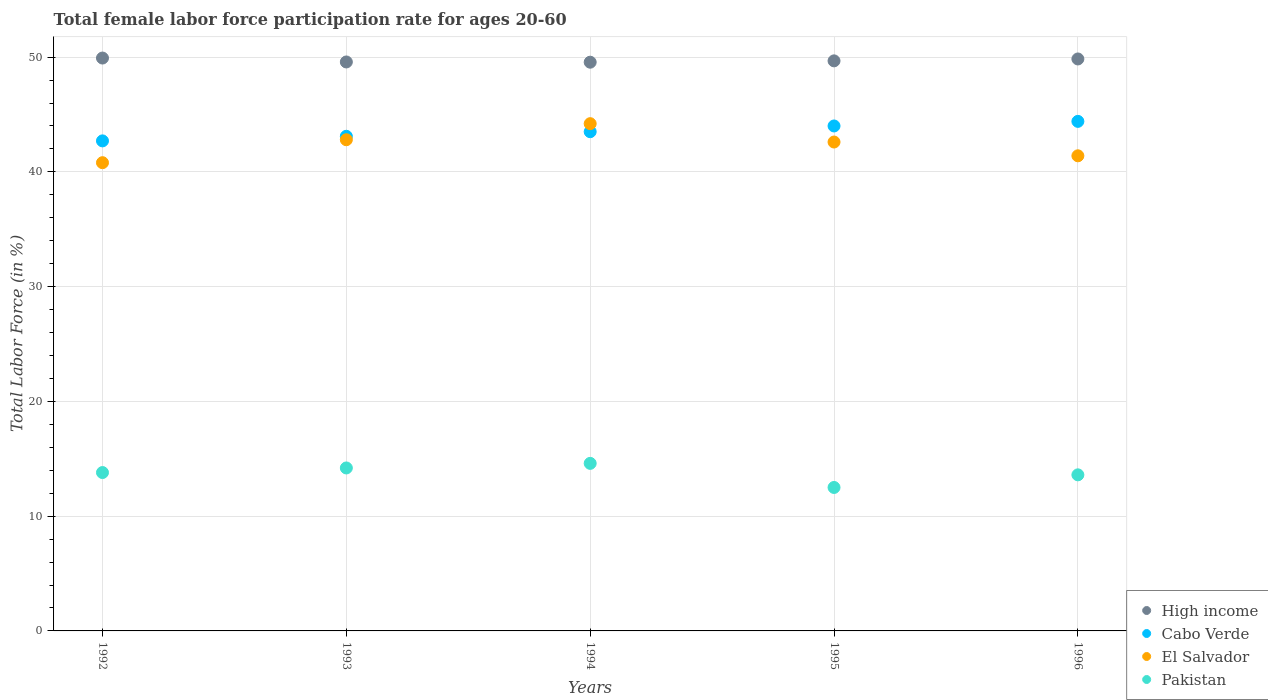What is the female labor force participation rate in Pakistan in 1996?
Offer a very short reply. 13.6. Across all years, what is the maximum female labor force participation rate in High income?
Give a very brief answer. 49.92. Across all years, what is the minimum female labor force participation rate in Cabo Verde?
Provide a short and direct response. 42.7. In which year was the female labor force participation rate in High income maximum?
Your response must be concise. 1992. In which year was the female labor force participation rate in Cabo Verde minimum?
Your response must be concise. 1992. What is the total female labor force participation rate in High income in the graph?
Ensure brevity in your answer.  248.56. What is the difference between the female labor force participation rate in El Salvador in 1992 and that in 1996?
Ensure brevity in your answer.  -0.6. What is the difference between the female labor force participation rate in El Salvador in 1993 and the female labor force participation rate in Cabo Verde in 1995?
Ensure brevity in your answer.  -1.2. What is the average female labor force participation rate in High income per year?
Provide a succinct answer. 49.71. In the year 1995, what is the difference between the female labor force participation rate in Pakistan and female labor force participation rate in High income?
Provide a succinct answer. -37.17. What is the ratio of the female labor force participation rate in Pakistan in 1993 to that in 1996?
Ensure brevity in your answer.  1.04. Is the female labor force participation rate in El Salvador in 1992 less than that in 1996?
Give a very brief answer. Yes. Is the difference between the female labor force participation rate in Pakistan in 1992 and 1995 greater than the difference between the female labor force participation rate in High income in 1992 and 1995?
Give a very brief answer. Yes. What is the difference between the highest and the second highest female labor force participation rate in Pakistan?
Your answer should be compact. 0.4. What is the difference between the highest and the lowest female labor force participation rate in High income?
Give a very brief answer. 0.36. In how many years, is the female labor force participation rate in El Salvador greater than the average female labor force participation rate in El Salvador taken over all years?
Give a very brief answer. 3. Is the sum of the female labor force participation rate in El Salvador in 1993 and 1994 greater than the maximum female labor force participation rate in Pakistan across all years?
Ensure brevity in your answer.  Yes. Does the female labor force participation rate in Cabo Verde monotonically increase over the years?
Provide a short and direct response. Yes. Is the female labor force participation rate in Pakistan strictly less than the female labor force participation rate in Cabo Verde over the years?
Ensure brevity in your answer.  Yes. Are the values on the major ticks of Y-axis written in scientific E-notation?
Offer a terse response. No. Where does the legend appear in the graph?
Provide a succinct answer. Bottom right. What is the title of the graph?
Your response must be concise. Total female labor force participation rate for ages 20-60. What is the Total Labor Force (in %) in High income in 1992?
Provide a short and direct response. 49.92. What is the Total Labor Force (in %) in Cabo Verde in 1992?
Provide a short and direct response. 42.7. What is the Total Labor Force (in %) in El Salvador in 1992?
Provide a short and direct response. 40.8. What is the Total Labor Force (in %) in Pakistan in 1992?
Keep it short and to the point. 13.8. What is the Total Labor Force (in %) of High income in 1993?
Offer a very short reply. 49.58. What is the Total Labor Force (in %) of Cabo Verde in 1993?
Ensure brevity in your answer.  43.1. What is the Total Labor Force (in %) of El Salvador in 1993?
Your answer should be compact. 42.8. What is the Total Labor Force (in %) in Pakistan in 1993?
Provide a succinct answer. 14.2. What is the Total Labor Force (in %) in High income in 1994?
Provide a short and direct response. 49.56. What is the Total Labor Force (in %) of Cabo Verde in 1994?
Offer a very short reply. 43.5. What is the Total Labor Force (in %) of El Salvador in 1994?
Ensure brevity in your answer.  44.2. What is the Total Labor Force (in %) of Pakistan in 1994?
Your answer should be very brief. 14.6. What is the Total Labor Force (in %) in High income in 1995?
Make the answer very short. 49.67. What is the Total Labor Force (in %) in Cabo Verde in 1995?
Your answer should be compact. 44. What is the Total Labor Force (in %) in El Salvador in 1995?
Keep it short and to the point. 42.6. What is the Total Labor Force (in %) in High income in 1996?
Make the answer very short. 49.84. What is the Total Labor Force (in %) in Cabo Verde in 1996?
Your answer should be compact. 44.4. What is the Total Labor Force (in %) in El Salvador in 1996?
Offer a terse response. 41.4. What is the Total Labor Force (in %) of Pakistan in 1996?
Your answer should be compact. 13.6. Across all years, what is the maximum Total Labor Force (in %) in High income?
Provide a succinct answer. 49.92. Across all years, what is the maximum Total Labor Force (in %) in Cabo Verde?
Your answer should be compact. 44.4. Across all years, what is the maximum Total Labor Force (in %) in El Salvador?
Your answer should be compact. 44.2. Across all years, what is the maximum Total Labor Force (in %) in Pakistan?
Keep it short and to the point. 14.6. Across all years, what is the minimum Total Labor Force (in %) of High income?
Provide a succinct answer. 49.56. Across all years, what is the minimum Total Labor Force (in %) in Cabo Verde?
Ensure brevity in your answer.  42.7. Across all years, what is the minimum Total Labor Force (in %) in El Salvador?
Offer a terse response. 40.8. What is the total Total Labor Force (in %) in High income in the graph?
Your answer should be compact. 248.56. What is the total Total Labor Force (in %) in Cabo Verde in the graph?
Make the answer very short. 217.7. What is the total Total Labor Force (in %) in El Salvador in the graph?
Make the answer very short. 211.8. What is the total Total Labor Force (in %) in Pakistan in the graph?
Your answer should be compact. 68.7. What is the difference between the Total Labor Force (in %) of High income in 1992 and that in 1993?
Your answer should be compact. 0.34. What is the difference between the Total Labor Force (in %) of Cabo Verde in 1992 and that in 1993?
Your answer should be very brief. -0.4. What is the difference between the Total Labor Force (in %) in High income in 1992 and that in 1994?
Your answer should be very brief. 0.36. What is the difference between the Total Labor Force (in %) of Cabo Verde in 1992 and that in 1994?
Offer a very short reply. -0.8. What is the difference between the Total Labor Force (in %) in El Salvador in 1992 and that in 1994?
Keep it short and to the point. -3.4. What is the difference between the Total Labor Force (in %) of High income in 1992 and that in 1995?
Ensure brevity in your answer.  0.25. What is the difference between the Total Labor Force (in %) in El Salvador in 1992 and that in 1995?
Your answer should be very brief. -1.8. What is the difference between the Total Labor Force (in %) in High income in 1992 and that in 1996?
Provide a succinct answer. 0.08. What is the difference between the Total Labor Force (in %) in El Salvador in 1992 and that in 1996?
Provide a short and direct response. -0.6. What is the difference between the Total Labor Force (in %) of Pakistan in 1992 and that in 1996?
Your answer should be compact. 0.2. What is the difference between the Total Labor Force (in %) of High income in 1993 and that in 1994?
Provide a short and direct response. 0.02. What is the difference between the Total Labor Force (in %) of Cabo Verde in 1993 and that in 1994?
Your response must be concise. -0.4. What is the difference between the Total Labor Force (in %) of High income in 1993 and that in 1995?
Ensure brevity in your answer.  -0.1. What is the difference between the Total Labor Force (in %) of Cabo Verde in 1993 and that in 1995?
Your response must be concise. -0.9. What is the difference between the Total Labor Force (in %) of Pakistan in 1993 and that in 1995?
Provide a succinct answer. 1.7. What is the difference between the Total Labor Force (in %) of High income in 1993 and that in 1996?
Give a very brief answer. -0.26. What is the difference between the Total Labor Force (in %) of Pakistan in 1993 and that in 1996?
Ensure brevity in your answer.  0.6. What is the difference between the Total Labor Force (in %) of High income in 1994 and that in 1995?
Offer a terse response. -0.12. What is the difference between the Total Labor Force (in %) in Cabo Verde in 1994 and that in 1995?
Ensure brevity in your answer.  -0.5. What is the difference between the Total Labor Force (in %) in El Salvador in 1994 and that in 1995?
Offer a very short reply. 1.6. What is the difference between the Total Labor Force (in %) in Pakistan in 1994 and that in 1995?
Make the answer very short. 2.1. What is the difference between the Total Labor Force (in %) in High income in 1994 and that in 1996?
Offer a very short reply. -0.28. What is the difference between the Total Labor Force (in %) in El Salvador in 1994 and that in 1996?
Give a very brief answer. 2.8. What is the difference between the Total Labor Force (in %) of High income in 1995 and that in 1996?
Give a very brief answer. -0.17. What is the difference between the Total Labor Force (in %) in High income in 1992 and the Total Labor Force (in %) in Cabo Verde in 1993?
Provide a short and direct response. 6.82. What is the difference between the Total Labor Force (in %) in High income in 1992 and the Total Labor Force (in %) in El Salvador in 1993?
Your answer should be compact. 7.12. What is the difference between the Total Labor Force (in %) of High income in 1992 and the Total Labor Force (in %) of Pakistan in 1993?
Your answer should be compact. 35.72. What is the difference between the Total Labor Force (in %) in El Salvador in 1992 and the Total Labor Force (in %) in Pakistan in 1993?
Ensure brevity in your answer.  26.6. What is the difference between the Total Labor Force (in %) of High income in 1992 and the Total Labor Force (in %) of Cabo Verde in 1994?
Give a very brief answer. 6.42. What is the difference between the Total Labor Force (in %) of High income in 1992 and the Total Labor Force (in %) of El Salvador in 1994?
Offer a terse response. 5.72. What is the difference between the Total Labor Force (in %) of High income in 1992 and the Total Labor Force (in %) of Pakistan in 1994?
Your answer should be very brief. 35.32. What is the difference between the Total Labor Force (in %) in Cabo Verde in 1992 and the Total Labor Force (in %) in El Salvador in 1994?
Your answer should be compact. -1.5. What is the difference between the Total Labor Force (in %) of Cabo Verde in 1992 and the Total Labor Force (in %) of Pakistan in 1994?
Give a very brief answer. 28.1. What is the difference between the Total Labor Force (in %) in El Salvador in 1992 and the Total Labor Force (in %) in Pakistan in 1994?
Your answer should be compact. 26.2. What is the difference between the Total Labor Force (in %) of High income in 1992 and the Total Labor Force (in %) of Cabo Verde in 1995?
Offer a very short reply. 5.92. What is the difference between the Total Labor Force (in %) of High income in 1992 and the Total Labor Force (in %) of El Salvador in 1995?
Ensure brevity in your answer.  7.32. What is the difference between the Total Labor Force (in %) in High income in 1992 and the Total Labor Force (in %) in Pakistan in 1995?
Your answer should be compact. 37.42. What is the difference between the Total Labor Force (in %) in Cabo Verde in 1992 and the Total Labor Force (in %) in Pakistan in 1995?
Provide a short and direct response. 30.2. What is the difference between the Total Labor Force (in %) in El Salvador in 1992 and the Total Labor Force (in %) in Pakistan in 1995?
Make the answer very short. 28.3. What is the difference between the Total Labor Force (in %) of High income in 1992 and the Total Labor Force (in %) of Cabo Verde in 1996?
Provide a short and direct response. 5.52. What is the difference between the Total Labor Force (in %) of High income in 1992 and the Total Labor Force (in %) of El Salvador in 1996?
Ensure brevity in your answer.  8.52. What is the difference between the Total Labor Force (in %) in High income in 1992 and the Total Labor Force (in %) in Pakistan in 1996?
Offer a very short reply. 36.32. What is the difference between the Total Labor Force (in %) in Cabo Verde in 1992 and the Total Labor Force (in %) in Pakistan in 1996?
Offer a very short reply. 29.1. What is the difference between the Total Labor Force (in %) in El Salvador in 1992 and the Total Labor Force (in %) in Pakistan in 1996?
Your answer should be very brief. 27.2. What is the difference between the Total Labor Force (in %) in High income in 1993 and the Total Labor Force (in %) in Cabo Verde in 1994?
Give a very brief answer. 6.08. What is the difference between the Total Labor Force (in %) of High income in 1993 and the Total Labor Force (in %) of El Salvador in 1994?
Keep it short and to the point. 5.38. What is the difference between the Total Labor Force (in %) in High income in 1993 and the Total Labor Force (in %) in Pakistan in 1994?
Keep it short and to the point. 34.98. What is the difference between the Total Labor Force (in %) in Cabo Verde in 1993 and the Total Labor Force (in %) in El Salvador in 1994?
Keep it short and to the point. -1.1. What is the difference between the Total Labor Force (in %) of Cabo Verde in 1993 and the Total Labor Force (in %) of Pakistan in 1994?
Offer a terse response. 28.5. What is the difference between the Total Labor Force (in %) of El Salvador in 1993 and the Total Labor Force (in %) of Pakistan in 1994?
Make the answer very short. 28.2. What is the difference between the Total Labor Force (in %) of High income in 1993 and the Total Labor Force (in %) of Cabo Verde in 1995?
Your answer should be compact. 5.58. What is the difference between the Total Labor Force (in %) of High income in 1993 and the Total Labor Force (in %) of El Salvador in 1995?
Your response must be concise. 6.98. What is the difference between the Total Labor Force (in %) in High income in 1993 and the Total Labor Force (in %) in Pakistan in 1995?
Provide a succinct answer. 37.08. What is the difference between the Total Labor Force (in %) in Cabo Verde in 1993 and the Total Labor Force (in %) in El Salvador in 1995?
Keep it short and to the point. 0.5. What is the difference between the Total Labor Force (in %) in Cabo Verde in 1993 and the Total Labor Force (in %) in Pakistan in 1995?
Your answer should be compact. 30.6. What is the difference between the Total Labor Force (in %) of El Salvador in 1993 and the Total Labor Force (in %) of Pakistan in 1995?
Offer a very short reply. 30.3. What is the difference between the Total Labor Force (in %) in High income in 1993 and the Total Labor Force (in %) in Cabo Verde in 1996?
Provide a short and direct response. 5.18. What is the difference between the Total Labor Force (in %) of High income in 1993 and the Total Labor Force (in %) of El Salvador in 1996?
Make the answer very short. 8.18. What is the difference between the Total Labor Force (in %) in High income in 1993 and the Total Labor Force (in %) in Pakistan in 1996?
Your answer should be compact. 35.98. What is the difference between the Total Labor Force (in %) of Cabo Verde in 1993 and the Total Labor Force (in %) of Pakistan in 1996?
Offer a very short reply. 29.5. What is the difference between the Total Labor Force (in %) of El Salvador in 1993 and the Total Labor Force (in %) of Pakistan in 1996?
Provide a short and direct response. 29.2. What is the difference between the Total Labor Force (in %) in High income in 1994 and the Total Labor Force (in %) in Cabo Verde in 1995?
Offer a very short reply. 5.56. What is the difference between the Total Labor Force (in %) in High income in 1994 and the Total Labor Force (in %) in El Salvador in 1995?
Give a very brief answer. 6.96. What is the difference between the Total Labor Force (in %) of High income in 1994 and the Total Labor Force (in %) of Pakistan in 1995?
Your answer should be compact. 37.06. What is the difference between the Total Labor Force (in %) in El Salvador in 1994 and the Total Labor Force (in %) in Pakistan in 1995?
Provide a short and direct response. 31.7. What is the difference between the Total Labor Force (in %) in High income in 1994 and the Total Labor Force (in %) in Cabo Verde in 1996?
Provide a short and direct response. 5.16. What is the difference between the Total Labor Force (in %) in High income in 1994 and the Total Labor Force (in %) in El Salvador in 1996?
Keep it short and to the point. 8.16. What is the difference between the Total Labor Force (in %) in High income in 1994 and the Total Labor Force (in %) in Pakistan in 1996?
Your answer should be compact. 35.96. What is the difference between the Total Labor Force (in %) in Cabo Verde in 1994 and the Total Labor Force (in %) in El Salvador in 1996?
Offer a terse response. 2.1. What is the difference between the Total Labor Force (in %) of Cabo Verde in 1994 and the Total Labor Force (in %) of Pakistan in 1996?
Offer a very short reply. 29.9. What is the difference between the Total Labor Force (in %) of El Salvador in 1994 and the Total Labor Force (in %) of Pakistan in 1996?
Provide a short and direct response. 30.6. What is the difference between the Total Labor Force (in %) of High income in 1995 and the Total Labor Force (in %) of Cabo Verde in 1996?
Ensure brevity in your answer.  5.27. What is the difference between the Total Labor Force (in %) of High income in 1995 and the Total Labor Force (in %) of El Salvador in 1996?
Ensure brevity in your answer.  8.27. What is the difference between the Total Labor Force (in %) of High income in 1995 and the Total Labor Force (in %) of Pakistan in 1996?
Provide a succinct answer. 36.07. What is the difference between the Total Labor Force (in %) in Cabo Verde in 1995 and the Total Labor Force (in %) in El Salvador in 1996?
Make the answer very short. 2.6. What is the difference between the Total Labor Force (in %) in Cabo Verde in 1995 and the Total Labor Force (in %) in Pakistan in 1996?
Your answer should be very brief. 30.4. What is the average Total Labor Force (in %) of High income per year?
Offer a terse response. 49.71. What is the average Total Labor Force (in %) of Cabo Verde per year?
Give a very brief answer. 43.54. What is the average Total Labor Force (in %) in El Salvador per year?
Your answer should be compact. 42.36. What is the average Total Labor Force (in %) of Pakistan per year?
Ensure brevity in your answer.  13.74. In the year 1992, what is the difference between the Total Labor Force (in %) of High income and Total Labor Force (in %) of Cabo Verde?
Make the answer very short. 7.22. In the year 1992, what is the difference between the Total Labor Force (in %) in High income and Total Labor Force (in %) in El Salvador?
Give a very brief answer. 9.12. In the year 1992, what is the difference between the Total Labor Force (in %) in High income and Total Labor Force (in %) in Pakistan?
Your response must be concise. 36.12. In the year 1992, what is the difference between the Total Labor Force (in %) of Cabo Verde and Total Labor Force (in %) of El Salvador?
Make the answer very short. 1.9. In the year 1992, what is the difference between the Total Labor Force (in %) in Cabo Verde and Total Labor Force (in %) in Pakistan?
Provide a succinct answer. 28.9. In the year 1993, what is the difference between the Total Labor Force (in %) of High income and Total Labor Force (in %) of Cabo Verde?
Make the answer very short. 6.48. In the year 1993, what is the difference between the Total Labor Force (in %) of High income and Total Labor Force (in %) of El Salvador?
Keep it short and to the point. 6.78. In the year 1993, what is the difference between the Total Labor Force (in %) of High income and Total Labor Force (in %) of Pakistan?
Your response must be concise. 35.38. In the year 1993, what is the difference between the Total Labor Force (in %) in Cabo Verde and Total Labor Force (in %) in Pakistan?
Keep it short and to the point. 28.9. In the year 1993, what is the difference between the Total Labor Force (in %) of El Salvador and Total Labor Force (in %) of Pakistan?
Your answer should be very brief. 28.6. In the year 1994, what is the difference between the Total Labor Force (in %) of High income and Total Labor Force (in %) of Cabo Verde?
Provide a short and direct response. 6.06. In the year 1994, what is the difference between the Total Labor Force (in %) of High income and Total Labor Force (in %) of El Salvador?
Make the answer very short. 5.36. In the year 1994, what is the difference between the Total Labor Force (in %) in High income and Total Labor Force (in %) in Pakistan?
Ensure brevity in your answer.  34.96. In the year 1994, what is the difference between the Total Labor Force (in %) in Cabo Verde and Total Labor Force (in %) in Pakistan?
Your answer should be very brief. 28.9. In the year 1994, what is the difference between the Total Labor Force (in %) of El Salvador and Total Labor Force (in %) of Pakistan?
Offer a very short reply. 29.6. In the year 1995, what is the difference between the Total Labor Force (in %) in High income and Total Labor Force (in %) in Cabo Verde?
Provide a short and direct response. 5.67. In the year 1995, what is the difference between the Total Labor Force (in %) in High income and Total Labor Force (in %) in El Salvador?
Offer a terse response. 7.07. In the year 1995, what is the difference between the Total Labor Force (in %) in High income and Total Labor Force (in %) in Pakistan?
Your answer should be very brief. 37.17. In the year 1995, what is the difference between the Total Labor Force (in %) in Cabo Verde and Total Labor Force (in %) in Pakistan?
Ensure brevity in your answer.  31.5. In the year 1995, what is the difference between the Total Labor Force (in %) of El Salvador and Total Labor Force (in %) of Pakistan?
Your response must be concise. 30.1. In the year 1996, what is the difference between the Total Labor Force (in %) in High income and Total Labor Force (in %) in Cabo Verde?
Your answer should be very brief. 5.44. In the year 1996, what is the difference between the Total Labor Force (in %) of High income and Total Labor Force (in %) of El Salvador?
Make the answer very short. 8.44. In the year 1996, what is the difference between the Total Labor Force (in %) in High income and Total Labor Force (in %) in Pakistan?
Provide a short and direct response. 36.24. In the year 1996, what is the difference between the Total Labor Force (in %) in Cabo Verde and Total Labor Force (in %) in Pakistan?
Give a very brief answer. 30.8. In the year 1996, what is the difference between the Total Labor Force (in %) of El Salvador and Total Labor Force (in %) of Pakistan?
Make the answer very short. 27.8. What is the ratio of the Total Labor Force (in %) in High income in 1992 to that in 1993?
Ensure brevity in your answer.  1.01. What is the ratio of the Total Labor Force (in %) in Cabo Verde in 1992 to that in 1993?
Offer a terse response. 0.99. What is the ratio of the Total Labor Force (in %) in El Salvador in 1992 to that in 1993?
Your answer should be compact. 0.95. What is the ratio of the Total Labor Force (in %) in Pakistan in 1992 to that in 1993?
Offer a very short reply. 0.97. What is the ratio of the Total Labor Force (in %) in High income in 1992 to that in 1994?
Your response must be concise. 1.01. What is the ratio of the Total Labor Force (in %) of Cabo Verde in 1992 to that in 1994?
Provide a succinct answer. 0.98. What is the ratio of the Total Labor Force (in %) of El Salvador in 1992 to that in 1994?
Provide a succinct answer. 0.92. What is the ratio of the Total Labor Force (in %) in Pakistan in 1992 to that in 1994?
Ensure brevity in your answer.  0.95. What is the ratio of the Total Labor Force (in %) of High income in 1992 to that in 1995?
Provide a succinct answer. 1. What is the ratio of the Total Labor Force (in %) in Cabo Verde in 1992 to that in 1995?
Your answer should be very brief. 0.97. What is the ratio of the Total Labor Force (in %) of El Salvador in 1992 to that in 1995?
Keep it short and to the point. 0.96. What is the ratio of the Total Labor Force (in %) in Pakistan in 1992 to that in 1995?
Make the answer very short. 1.1. What is the ratio of the Total Labor Force (in %) in High income in 1992 to that in 1996?
Your answer should be compact. 1. What is the ratio of the Total Labor Force (in %) of Cabo Verde in 1992 to that in 1996?
Provide a succinct answer. 0.96. What is the ratio of the Total Labor Force (in %) of El Salvador in 1992 to that in 1996?
Provide a succinct answer. 0.99. What is the ratio of the Total Labor Force (in %) of Pakistan in 1992 to that in 1996?
Provide a succinct answer. 1.01. What is the ratio of the Total Labor Force (in %) of Cabo Verde in 1993 to that in 1994?
Give a very brief answer. 0.99. What is the ratio of the Total Labor Force (in %) in El Salvador in 1993 to that in 1994?
Give a very brief answer. 0.97. What is the ratio of the Total Labor Force (in %) in Pakistan in 1993 to that in 1994?
Your answer should be compact. 0.97. What is the ratio of the Total Labor Force (in %) in Cabo Verde in 1993 to that in 1995?
Offer a terse response. 0.98. What is the ratio of the Total Labor Force (in %) in Pakistan in 1993 to that in 1995?
Keep it short and to the point. 1.14. What is the ratio of the Total Labor Force (in %) of High income in 1993 to that in 1996?
Your response must be concise. 0.99. What is the ratio of the Total Labor Force (in %) of Cabo Verde in 1993 to that in 1996?
Provide a succinct answer. 0.97. What is the ratio of the Total Labor Force (in %) in El Salvador in 1993 to that in 1996?
Ensure brevity in your answer.  1.03. What is the ratio of the Total Labor Force (in %) of Pakistan in 1993 to that in 1996?
Make the answer very short. 1.04. What is the ratio of the Total Labor Force (in %) of High income in 1994 to that in 1995?
Your answer should be very brief. 1. What is the ratio of the Total Labor Force (in %) of Cabo Verde in 1994 to that in 1995?
Your response must be concise. 0.99. What is the ratio of the Total Labor Force (in %) in El Salvador in 1994 to that in 1995?
Offer a very short reply. 1.04. What is the ratio of the Total Labor Force (in %) in Pakistan in 1994 to that in 1995?
Offer a terse response. 1.17. What is the ratio of the Total Labor Force (in %) of High income in 1994 to that in 1996?
Give a very brief answer. 0.99. What is the ratio of the Total Labor Force (in %) in Cabo Verde in 1994 to that in 1996?
Ensure brevity in your answer.  0.98. What is the ratio of the Total Labor Force (in %) of El Salvador in 1994 to that in 1996?
Ensure brevity in your answer.  1.07. What is the ratio of the Total Labor Force (in %) in Pakistan in 1994 to that in 1996?
Give a very brief answer. 1.07. What is the ratio of the Total Labor Force (in %) of Cabo Verde in 1995 to that in 1996?
Offer a terse response. 0.99. What is the ratio of the Total Labor Force (in %) in El Salvador in 1995 to that in 1996?
Your answer should be very brief. 1.03. What is the ratio of the Total Labor Force (in %) in Pakistan in 1995 to that in 1996?
Give a very brief answer. 0.92. What is the difference between the highest and the second highest Total Labor Force (in %) of High income?
Make the answer very short. 0.08. What is the difference between the highest and the second highest Total Labor Force (in %) in Cabo Verde?
Ensure brevity in your answer.  0.4. What is the difference between the highest and the second highest Total Labor Force (in %) of Pakistan?
Your answer should be very brief. 0.4. What is the difference between the highest and the lowest Total Labor Force (in %) in High income?
Your response must be concise. 0.36. What is the difference between the highest and the lowest Total Labor Force (in %) in Cabo Verde?
Make the answer very short. 1.7. What is the difference between the highest and the lowest Total Labor Force (in %) in Pakistan?
Your answer should be very brief. 2.1. 